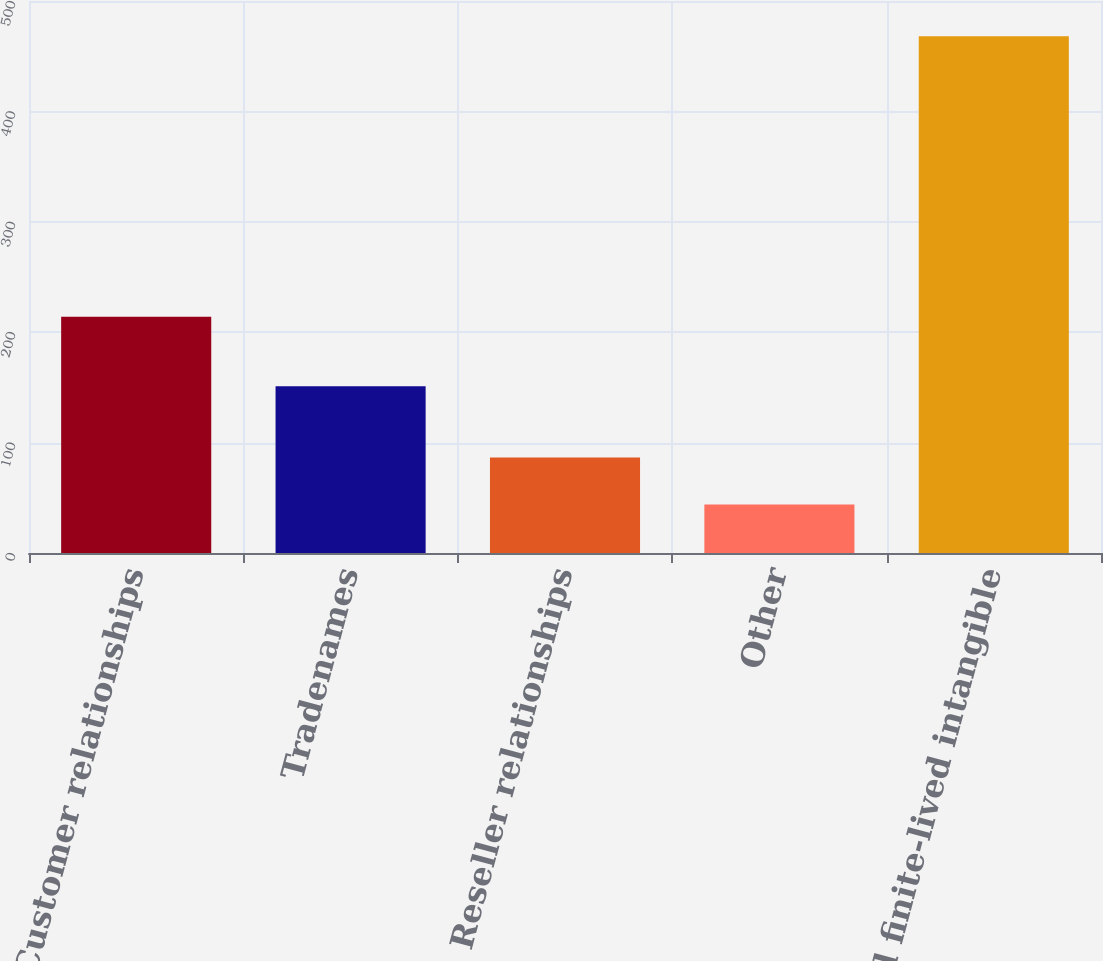Convert chart. <chart><loc_0><loc_0><loc_500><loc_500><bar_chart><fcel>Customer relationships<fcel>Tradenames<fcel>Reseller relationships<fcel>Other<fcel>Total finite-lived intangible<nl><fcel>214<fcel>151<fcel>86.4<fcel>44<fcel>468<nl></chart> 